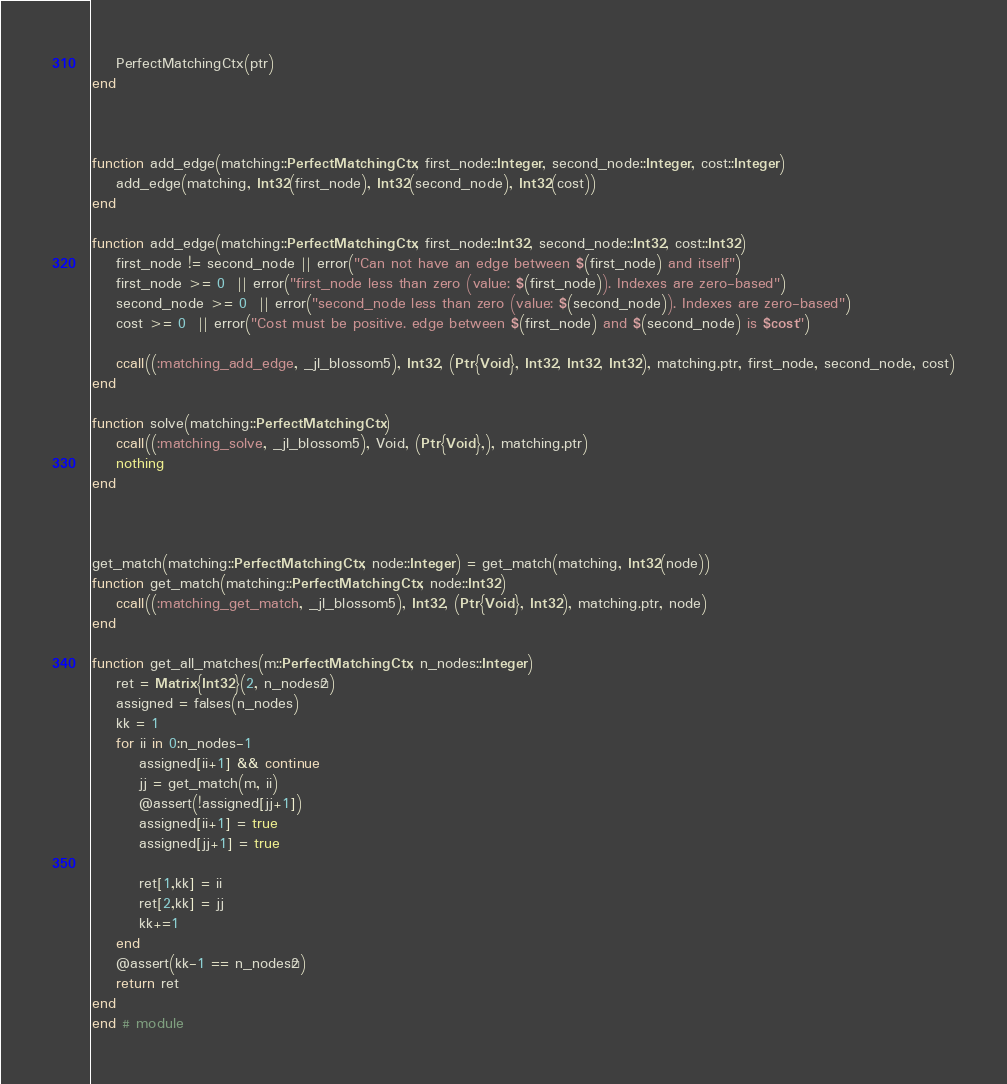Convert code to text. <code><loc_0><loc_0><loc_500><loc_500><_Julia_>    PerfectMatchingCtx(ptr)
end



function add_edge(matching::PerfectMatchingCtx, first_node::Integer, second_node::Integer, cost::Integer)
	add_edge(matching, Int32(first_node), Int32(second_node), Int32(cost))
end

function add_edge(matching::PerfectMatchingCtx, first_node::Int32, second_node::Int32, cost::Int32)
    first_node != second_node || error("Can not have an edge between $(first_node) and itself")
    first_node >= 0  || error("first_node less than zero (value: $(first_node)). Indexes are zero-based")
    second_node >= 0  || error("second_node less than zero (value: $(second_node)). Indexes are zero-based")
    cost >= 0  || error("Cost must be positive. edge between $(first_node) and $(second_node) is $cost")

	ccall((:matching_add_edge, _jl_blossom5), Int32, (Ptr{Void}, Int32, Int32, Int32), matching.ptr, first_node, second_node, cost)
end

function solve(matching::PerfectMatchingCtx)
    ccall((:matching_solve, _jl_blossom5), Void, (Ptr{Void},), matching.ptr)
    nothing
end



get_match(matching::PerfectMatchingCtx, node::Integer) = get_match(matching, Int32(node))
function get_match(matching::PerfectMatchingCtx, node::Int32)
    ccall((:matching_get_match, _jl_blossom5), Int32, (Ptr{Void}, Int32), matching.ptr, node)
end

function get_all_matches(m::PerfectMatchingCtx, n_nodes::Integer) 
    ret = Matrix{Int32}(2, n_nodes÷2)
    assigned = falses(n_nodes)
    kk = 1
    for ii in 0:n_nodes-1
        assigned[ii+1] && continue
        jj = get_match(m, ii)
        @assert(!assigned[jj+1])
        assigned[ii+1] = true
        assigned[jj+1] = true
        
        ret[1,kk] = ii
        ret[2,kk] = jj
        kk+=1
    end
    @assert(kk-1 == n_nodes÷2)
    return ret
end
end # module
</code> 